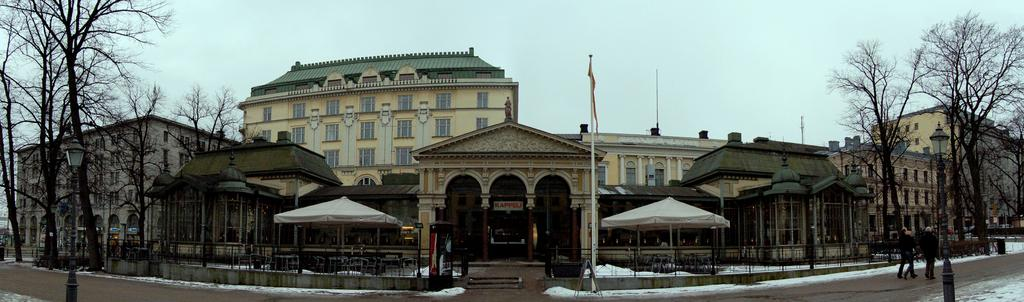What type of structures can be seen in the image? There are buildings in the image. What other natural elements are present in the image? There are trees in the image. What are the people in the image doing? The people are on the road in the image. What symbol can be seen in the image? There is a flag in the image. What can be seen in the background of the image? The sky is visible in the background of the image. What type of lighting is present in the image? Street lights are present in the image. What weather condition is depicted in the image? Snow is visible in the image. What type of tub is visible in the image? There is no tub present in the image. What sense is being used by the people in the image? The provided facts do not give information about the senses being used by the people in the image. 